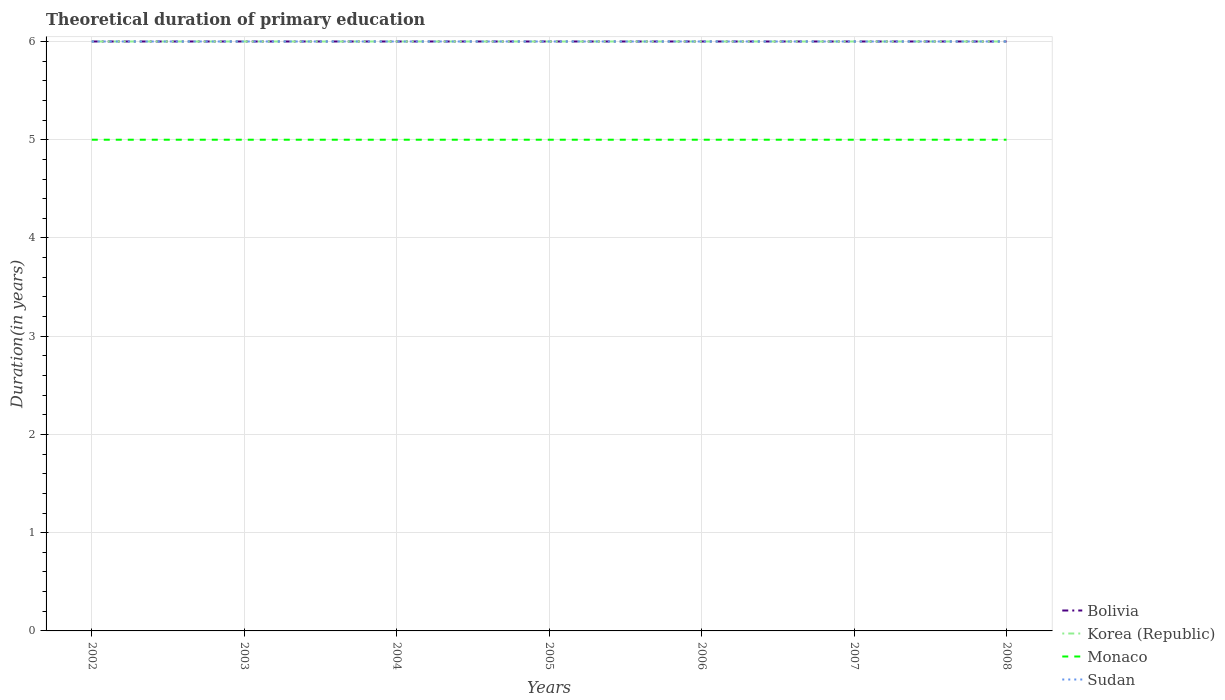How many different coloured lines are there?
Keep it short and to the point. 4. Across all years, what is the maximum total theoretical duration of primary education in Monaco?
Keep it short and to the point. 5. In which year was the total theoretical duration of primary education in Korea (Republic) maximum?
Make the answer very short. 2002. What is the difference between the highest and the second highest total theoretical duration of primary education in Sudan?
Your answer should be very brief. 0. Is the total theoretical duration of primary education in Korea (Republic) strictly greater than the total theoretical duration of primary education in Bolivia over the years?
Make the answer very short. No. Are the values on the major ticks of Y-axis written in scientific E-notation?
Make the answer very short. No. Does the graph contain grids?
Offer a very short reply. Yes. How are the legend labels stacked?
Your answer should be compact. Vertical. What is the title of the graph?
Ensure brevity in your answer.  Theoretical duration of primary education. Does "East Asia (developing only)" appear as one of the legend labels in the graph?
Make the answer very short. No. What is the label or title of the Y-axis?
Give a very brief answer. Duration(in years). What is the Duration(in years) in Bolivia in 2002?
Offer a very short reply. 6. What is the Duration(in years) of Korea (Republic) in 2002?
Provide a short and direct response. 6. What is the Duration(in years) of Monaco in 2002?
Offer a very short reply. 5. What is the Duration(in years) in Bolivia in 2003?
Provide a succinct answer. 6. What is the Duration(in years) of Korea (Republic) in 2003?
Offer a terse response. 6. What is the Duration(in years) of Monaco in 2003?
Offer a very short reply. 5. What is the Duration(in years) in Bolivia in 2004?
Your response must be concise. 6. What is the Duration(in years) in Korea (Republic) in 2004?
Give a very brief answer. 6. What is the Duration(in years) in Monaco in 2004?
Offer a terse response. 5. What is the Duration(in years) in Sudan in 2004?
Offer a terse response. 6. What is the Duration(in years) of Bolivia in 2005?
Make the answer very short. 6. What is the Duration(in years) of Korea (Republic) in 2005?
Your response must be concise. 6. What is the Duration(in years) of Monaco in 2006?
Your answer should be compact. 5. What is the Duration(in years) in Sudan in 2006?
Provide a succinct answer. 6. What is the Duration(in years) of Bolivia in 2007?
Offer a terse response. 6. What is the Duration(in years) in Monaco in 2008?
Your answer should be compact. 5. Across all years, what is the maximum Duration(in years) in Bolivia?
Offer a very short reply. 6. Across all years, what is the maximum Duration(in years) of Korea (Republic)?
Give a very brief answer. 6. Across all years, what is the maximum Duration(in years) of Monaco?
Provide a succinct answer. 5. Across all years, what is the minimum Duration(in years) of Monaco?
Ensure brevity in your answer.  5. What is the total Duration(in years) of Korea (Republic) in the graph?
Give a very brief answer. 42. What is the difference between the Duration(in years) in Bolivia in 2002 and that in 2004?
Your answer should be compact. 0. What is the difference between the Duration(in years) in Monaco in 2002 and that in 2004?
Ensure brevity in your answer.  0. What is the difference between the Duration(in years) of Sudan in 2002 and that in 2004?
Your response must be concise. 0. What is the difference between the Duration(in years) in Monaco in 2002 and that in 2005?
Offer a very short reply. 0. What is the difference between the Duration(in years) in Sudan in 2002 and that in 2005?
Provide a succinct answer. 0. What is the difference between the Duration(in years) of Korea (Republic) in 2002 and that in 2006?
Provide a short and direct response. 0. What is the difference between the Duration(in years) in Monaco in 2002 and that in 2006?
Make the answer very short. 0. What is the difference between the Duration(in years) of Bolivia in 2002 and that in 2008?
Offer a terse response. 0. What is the difference between the Duration(in years) in Korea (Republic) in 2002 and that in 2008?
Offer a terse response. 0. What is the difference between the Duration(in years) of Monaco in 2002 and that in 2008?
Provide a short and direct response. 0. What is the difference between the Duration(in years) in Korea (Republic) in 2003 and that in 2004?
Keep it short and to the point. 0. What is the difference between the Duration(in years) of Monaco in 2003 and that in 2004?
Give a very brief answer. 0. What is the difference between the Duration(in years) in Sudan in 2003 and that in 2004?
Offer a terse response. 0. What is the difference between the Duration(in years) in Monaco in 2003 and that in 2005?
Your response must be concise. 0. What is the difference between the Duration(in years) of Bolivia in 2003 and that in 2006?
Offer a terse response. 0. What is the difference between the Duration(in years) of Monaco in 2003 and that in 2006?
Give a very brief answer. 0. What is the difference between the Duration(in years) in Bolivia in 2003 and that in 2007?
Your answer should be very brief. 0. What is the difference between the Duration(in years) in Sudan in 2003 and that in 2008?
Offer a terse response. 0. What is the difference between the Duration(in years) in Korea (Republic) in 2004 and that in 2005?
Give a very brief answer. 0. What is the difference between the Duration(in years) in Sudan in 2004 and that in 2005?
Your response must be concise. 0. What is the difference between the Duration(in years) of Korea (Republic) in 2004 and that in 2006?
Give a very brief answer. 0. What is the difference between the Duration(in years) in Korea (Republic) in 2004 and that in 2007?
Make the answer very short. 0. What is the difference between the Duration(in years) in Monaco in 2004 and that in 2007?
Keep it short and to the point. 0. What is the difference between the Duration(in years) of Sudan in 2004 and that in 2007?
Your response must be concise. 0. What is the difference between the Duration(in years) in Korea (Republic) in 2004 and that in 2008?
Your answer should be compact. 0. What is the difference between the Duration(in years) of Sudan in 2004 and that in 2008?
Your response must be concise. 0. What is the difference between the Duration(in years) in Bolivia in 2005 and that in 2006?
Keep it short and to the point. 0. What is the difference between the Duration(in years) in Korea (Republic) in 2005 and that in 2006?
Ensure brevity in your answer.  0. What is the difference between the Duration(in years) of Bolivia in 2005 and that in 2007?
Offer a very short reply. 0. What is the difference between the Duration(in years) in Korea (Republic) in 2005 and that in 2008?
Your answer should be very brief. 0. What is the difference between the Duration(in years) in Monaco in 2005 and that in 2008?
Give a very brief answer. 0. What is the difference between the Duration(in years) in Bolivia in 2006 and that in 2008?
Give a very brief answer. 0. What is the difference between the Duration(in years) of Monaco in 2006 and that in 2008?
Ensure brevity in your answer.  0. What is the difference between the Duration(in years) in Monaco in 2007 and that in 2008?
Your response must be concise. 0. What is the difference between the Duration(in years) in Bolivia in 2002 and the Duration(in years) in Korea (Republic) in 2003?
Keep it short and to the point. 0. What is the difference between the Duration(in years) of Korea (Republic) in 2002 and the Duration(in years) of Monaco in 2003?
Offer a very short reply. 1. What is the difference between the Duration(in years) of Bolivia in 2002 and the Duration(in years) of Sudan in 2004?
Your answer should be compact. 0. What is the difference between the Duration(in years) in Korea (Republic) in 2002 and the Duration(in years) in Monaco in 2004?
Ensure brevity in your answer.  1. What is the difference between the Duration(in years) in Monaco in 2002 and the Duration(in years) in Sudan in 2004?
Give a very brief answer. -1. What is the difference between the Duration(in years) in Bolivia in 2002 and the Duration(in years) in Monaco in 2005?
Ensure brevity in your answer.  1. What is the difference between the Duration(in years) of Bolivia in 2002 and the Duration(in years) of Korea (Republic) in 2006?
Offer a very short reply. 0. What is the difference between the Duration(in years) of Bolivia in 2002 and the Duration(in years) of Monaco in 2006?
Your answer should be very brief. 1. What is the difference between the Duration(in years) of Bolivia in 2002 and the Duration(in years) of Sudan in 2006?
Ensure brevity in your answer.  0. What is the difference between the Duration(in years) in Korea (Republic) in 2002 and the Duration(in years) in Monaco in 2006?
Keep it short and to the point. 1. What is the difference between the Duration(in years) in Korea (Republic) in 2002 and the Duration(in years) in Sudan in 2006?
Ensure brevity in your answer.  0. What is the difference between the Duration(in years) of Bolivia in 2002 and the Duration(in years) of Korea (Republic) in 2007?
Ensure brevity in your answer.  0. What is the difference between the Duration(in years) of Bolivia in 2002 and the Duration(in years) of Sudan in 2008?
Provide a succinct answer. 0. What is the difference between the Duration(in years) in Korea (Republic) in 2002 and the Duration(in years) in Monaco in 2008?
Keep it short and to the point. 1. What is the difference between the Duration(in years) of Monaco in 2002 and the Duration(in years) of Sudan in 2008?
Provide a succinct answer. -1. What is the difference between the Duration(in years) of Bolivia in 2003 and the Duration(in years) of Monaco in 2004?
Your answer should be compact. 1. What is the difference between the Duration(in years) in Monaco in 2003 and the Duration(in years) in Sudan in 2004?
Provide a succinct answer. -1. What is the difference between the Duration(in years) of Korea (Republic) in 2003 and the Duration(in years) of Sudan in 2005?
Offer a very short reply. 0. What is the difference between the Duration(in years) in Monaco in 2003 and the Duration(in years) in Sudan in 2005?
Keep it short and to the point. -1. What is the difference between the Duration(in years) of Korea (Republic) in 2003 and the Duration(in years) of Monaco in 2006?
Your response must be concise. 1. What is the difference between the Duration(in years) of Bolivia in 2003 and the Duration(in years) of Monaco in 2007?
Your response must be concise. 1. What is the difference between the Duration(in years) of Korea (Republic) in 2003 and the Duration(in years) of Monaco in 2007?
Provide a succinct answer. 1. What is the difference between the Duration(in years) of Korea (Republic) in 2003 and the Duration(in years) of Sudan in 2007?
Offer a terse response. 0. What is the difference between the Duration(in years) in Monaco in 2003 and the Duration(in years) in Sudan in 2007?
Offer a very short reply. -1. What is the difference between the Duration(in years) in Bolivia in 2003 and the Duration(in years) in Korea (Republic) in 2008?
Offer a very short reply. 0. What is the difference between the Duration(in years) of Bolivia in 2003 and the Duration(in years) of Sudan in 2008?
Provide a succinct answer. 0. What is the difference between the Duration(in years) of Korea (Republic) in 2003 and the Duration(in years) of Monaco in 2008?
Keep it short and to the point. 1. What is the difference between the Duration(in years) in Korea (Republic) in 2004 and the Duration(in years) in Sudan in 2005?
Your answer should be very brief. 0. What is the difference between the Duration(in years) in Bolivia in 2004 and the Duration(in years) in Sudan in 2006?
Ensure brevity in your answer.  0. What is the difference between the Duration(in years) in Korea (Republic) in 2004 and the Duration(in years) in Monaco in 2006?
Offer a very short reply. 1. What is the difference between the Duration(in years) of Korea (Republic) in 2004 and the Duration(in years) of Sudan in 2006?
Make the answer very short. 0. What is the difference between the Duration(in years) of Bolivia in 2004 and the Duration(in years) of Korea (Republic) in 2007?
Offer a terse response. 0. What is the difference between the Duration(in years) in Korea (Republic) in 2004 and the Duration(in years) in Monaco in 2007?
Your response must be concise. 1. What is the difference between the Duration(in years) of Korea (Republic) in 2004 and the Duration(in years) of Sudan in 2007?
Offer a very short reply. 0. What is the difference between the Duration(in years) of Bolivia in 2004 and the Duration(in years) of Korea (Republic) in 2008?
Make the answer very short. 0. What is the difference between the Duration(in years) in Bolivia in 2004 and the Duration(in years) in Monaco in 2008?
Make the answer very short. 1. What is the difference between the Duration(in years) in Monaco in 2004 and the Duration(in years) in Sudan in 2008?
Keep it short and to the point. -1. What is the difference between the Duration(in years) of Bolivia in 2005 and the Duration(in years) of Monaco in 2006?
Your answer should be very brief. 1. What is the difference between the Duration(in years) of Korea (Republic) in 2005 and the Duration(in years) of Monaco in 2006?
Keep it short and to the point. 1. What is the difference between the Duration(in years) of Korea (Republic) in 2005 and the Duration(in years) of Sudan in 2006?
Provide a short and direct response. 0. What is the difference between the Duration(in years) of Bolivia in 2005 and the Duration(in years) of Sudan in 2007?
Make the answer very short. 0. What is the difference between the Duration(in years) of Korea (Republic) in 2005 and the Duration(in years) of Monaco in 2007?
Your response must be concise. 1. What is the difference between the Duration(in years) in Korea (Republic) in 2005 and the Duration(in years) in Sudan in 2007?
Provide a succinct answer. 0. What is the difference between the Duration(in years) of Bolivia in 2005 and the Duration(in years) of Korea (Republic) in 2008?
Offer a very short reply. 0. What is the difference between the Duration(in years) of Bolivia in 2005 and the Duration(in years) of Monaco in 2008?
Make the answer very short. 1. What is the difference between the Duration(in years) in Bolivia in 2005 and the Duration(in years) in Sudan in 2008?
Give a very brief answer. 0. What is the difference between the Duration(in years) of Korea (Republic) in 2005 and the Duration(in years) of Monaco in 2008?
Your answer should be very brief. 1. What is the difference between the Duration(in years) in Monaco in 2005 and the Duration(in years) in Sudan in 2008?
Provide a succinct answer. -1. What is the difference between the Duration(in years) in Bolivia in 2006 and the Duration(in years) in Monaco in 2007?
Keep it short and to the point. 1. What is the difference between the Duration(in years) in Korea (Republic) in 2006 and the Duration(in years) in Sudan in 2007?
Provide a short and direct response. 0. What is the difference between the Duration(in years) of Bolivia in 2006 and the Duration(in years) of Korea (Republic) in 2008?
Provide a short and direct response. 0. What is the difference between the Duration(in years) of Bolivia in 2006 and the Duration(in years) of Monaco in 2008?
Make the answer very short. 1. What is the difference between the Duration(in years) in Korea (Republic) in 2006 and the Duration(in years) in Monaco in 2008?
Offer a very short reply. 1. What is the difference between the Duration(in years) of Korea (Republic) in 2006 and the Duration(in years) of Sudan in 2008?
Provide a succinct answer. 0. What is the difference between the Duration(in years) of Monaco in 2006 and the Duration(in years) of Sudan in 2008?
Offer a terse response. -1. What is the difference between the Duration(in years) in Bolivia in 2007 and the Duration(in years) in Sudan in 2008?
Provide a succinct answer. 0. What is the difference between the Duration(in years) of Monaco in 2007 and the Duration(in years) of Sudan in 2008?
Offer a very short reply. -1. What is the average Duration(in years) of Korea (Republic) per year?
Your answer should be very brief. 6. What is the average Duration(in years) of Monaco per year?
Ensure brevity in your answer.  5. In the year 2002, what is the difference between the Duration(in years) in Korea (Republic) and Duration(in years) in Sudan?
Give a very brief answer. 0. In the year 2003, what is the difference between the Duration(in years) of Bolivia and Duration(in years) of Korea (Republic)?
Make the answer very short. 0. In the year 2003, what is the difference between the Duration(in years) of Bolivia and Duration(in years) of Sudan?
Provide a short and direct response. 0. In the year 2003, what is the difference between the Duration(in years) of Korea (Republic) and Duration(in years) of Monaco?
Your answer should be very brief. 1. In the year 2003, what is the difference between the Duration(in years) of Korea (Republic) and Duration(in years) of Sudan?
Your answer should be very brief. 0. In the year 2003, what is the difference between the Duration(in years) of Monaco and Duration(in years) of Sudan?
Your answer should be compact. -1. In the year 2004, what is the difference between the Duration(in years) of Bolivia and Duration(in years) of Monaco?
Ensure brevity in your answer.  1. In the year 2004, what is the difference between the Duration(in years) in Korea (Republic) and Duration(in years) in Monaco?
Keep it short and to the point. 1. In the year 2004, what is the difference between the Duration(in years) of Korea (Republic) and Duration(in years) of Sudan?
Your answer should be very brief. 0. In the year 2004, what is the difference between the Duration(in years) of Monaco and Duration(in years) of Sudan?
Give a very brief answer. -1. In the year 2005, what is the difference between the Duration(in years) of Bolivia and Duration(in years) of Korea (Republic)?
Ensure brevity in your answer.  0. In the year 2005, what is the difference between the Duration(in years) in Bolivia and Duration(in years) in Monaco?
Provide a succinct answer. 1. In the year 2005, what is the difference between the Duration(in years) of Bolivia and Duration(in years) of Sudan?
Give a very brief answer. 0. In the year 2005, what is the difference between the Duration(in years) of Korea (Republic) and Duration(in years) of Monaco?
Your answer should be compact. 1. In the year 2005, what is the difference between the Duration(in years) in Monaco and Duration(in years) in Sudan?
Your response must be concise. -1. In the year 2006, what is the difference between the Duration(in years) in Bolivia and Duration(in years) in Korea (Republic)?
Provide a short and direct response. 0. In the year 2006, what is the difference between the Duration(in years) in Bolivia and Duration(in years) in Monaco?
Offer a terse response. 1. In the year 2006, what is the difference between the Duration(in years) in Bolivia and Duration(in years) in Sudan?
Keep it short and to the point. 0. In the year 2006, what is the difference between the Duration(in years) of Korea (Republic) and Duration(in years) of Monaco?
Keep it short and to the point. 1. In the year 2007, what is the difference between the Duration(in years) of Bolivia and Duration(in years) of Korea (Republic)?
Keep it short and to the point. 0. In the year 2007, what is the difference between the Duration(in years) of Bolivia and Duration(in years) of Monaco?
Provide a succinct answer. 1. In the year 2007, what is the difference between the Duration(in years) in Korea (Republic) and Duration(in years) in Monaco?
Offer a very short reply. 1. In the year 2007, what is the difference between the Duration(in years) of Korea (Republic) and Duration(in years) of Sudan?
Offer a terse response. 0. In the year 2007, what is the difference between the Duration(in years) in Monaco and Duration(in years) in Sudan?
Provide a short and direct response. -1. In the year 2008, what is the difference between the Duration(in years) in Bolivia and Duration(in years) in Korea (Republic)?
Make the answer very short. 0. In the year 2008, what is the difference between the Duration(in years) of Bolivia and Duration(in years) of Sudan?
Your answer should be very brief. 0. In the year 2008, what is the difference between the Duration(in years) in Korea (Republic) and Duration(in years) in Sudan?
Provide a succinct answer. 0. In the year 2008, what is the difference between the Duration(in years) of Monaco and Duration(in years) of Sudan?
Your answer should be very brief. -1. What is the ratio of the Duration(in years) of Bolivia in 2002 to that in 2003?
Keep it short and to the point. 1. What is the ratio of the Duration(in years) of Korea (Republic) in 2002 to that in 2003?
Provide a short and direct response. 1. What is the ratio of the Duration(in years) of Monaco in 2002 to that in 2003?
Offer a terse response. 1. What is the ratio of the Duration(in years) in Sudan in 2002 to that in 2003?
Provide a short and direct response. 1. What is the ratio of the Duration(in years) of Korea (Republic) in 2002 to that in 2004?
Make the answer very short. 1. What is the ratio of the Duration(in years) in Monaco in 2002 to that in 2004?
Offer a terse response. 1. What is the ratio of the Duration(in years) of Sudan in 2002 to that in 2004?
Ensure brevity in your answer.  1. What is the ratio of the Duration(in years) in Bolivia in 2002 to that in 2005?
Provide a short and direct response. 1. What is the ratio of the Duration(in years) in Sudan in 2002 to that in 2005?
Ensure brevity in your answer.  1. What is the ratio of the Duration(in years) of Sudan in 2002 to that in 2006?
Your answer should be very brief. 1. What is the ratio of the Duration(in years) of Korea (Republic) in 2002 to that in 2007?
Offer a terse response. 1. What is the ratio of the Duration(in years) of Monaco in 2002 to that in 2007?
Provide a short and direct response. 1. What is the ratio of the Duration(in years) in Sudan in 2002 to that in 2007?
Make the answer very short. 1. What is the ratio of the Duration(in years) in Bolivia in 2002 to that in 2008?
Give a very brief answer. 1. What is the ratio of the Duration(in years) of Sudan in 2002 to that in 2008?
Make the answer very short. 1. What is the ratio of the Duration(in years) in Korea (Republic) in 2003 to that in 2004?
Ensure brevity in your answer.  1. What is the ratio of the Duration(in years) of Monaco in 2003 to that in 2005?
Your answer should be compact. 1. What is the ratio of the Duration(in years) of Sudan in 2003 to that in 2005?
Provide a short and direct response. 1. What is the ratio of the Duration(in years) of Bolivia in 2003 to that in 2006?
Offer a terse response. 1. What is the ratio of the Duration(in years) of Korea (Republic) in 2003 to that in 2006?
Give a very brief answer. 1. What is the ratio of the Duration(in years) in Monaco in 2003 to that in 2006?
Your answer should be very brief. 1. What is the ratio of the Duration(in years) in Sudan in 2003 to that in 2006?
Offer a terse response. 1. What is the ratio of the Duration(in years) in Korea (Republic) in 2003 to that in 2007?
Your response must be concise. 1. What is the ratio of the Duration(in years) in Sudan in 2003 to that in 2007?
Make the answer very short. 1. What is the ratio of the Duration(in years) in Sudan in 2003 to that in 2008?
Provide a short and direct response. 1. What is the ratio of the Duration(in years) in Korea (Republic) in 2004 to that in 2005?
Provide a succinct answer. 1. What is the ratio of the Duration(in years) of Monaco in 2004 to that in 2005?
Give a very brief answer. 1. What is the ratio of the Duration(in years) in Monaco in 2004 to that in 2006?
Give a very brief answer. 1. What is the ratio of the Duration(in years) of Korea (Republic) in 2004 to that in 2008?
Ensure brevity in your answer.  1. What is the ratio of the Duration(in years) in Sudan in 2004 to that in 2008?
Your response must be concise. 1. What is the ratio of the Duration(in years) in Bolivia in 2005 to that in 2006?
Ensure brevity in your answer.  1. What is the ratio of the Duration(in years) of Monaco in 2005 to that in 2006?
Make the answer very short. 1. What is the ratio of the Duration(in years) of Monaco in 2005 to that in 2007?
Your response must be concise. 1. What is the ratio of the Duration(in years) of Bolivia in 2005 to that in 2008?
Give a very brief answer. 1. What is the ratio of the Duration(in years) of Sudan in 2005 to that in 2008?
Make the answer very short. 1. What is the ratio of the Duration(in years) of Bolivia in 2006 to that in 2007?
Your answer should be very brief. 1. What is the ratio of the Duration(in years) of Korea (Republic) in 2006 to that in 2007?
Keep it short and to the point. 1. What is the ratio of the Duration(in years) of Monaco in 2006 to that in 2007?
Your response must be concise. 1. What is the ratio of the Duration(in years) of Sudan in 2006 to that in 2007?
Your response must be concise. 1. What is the ratio of the Duration(in years) of Bolivia in 2007 to that in 2008?
Ensure brevity in your answer.  1. What is the ratio of the Duration(in years) in Korea (Republic) in 2007 to that in 2008?
Give a very brief answer. 1. What is the ratio of the Duration(in years) of Monaco in 2007 to that in 2008?
Make the answer very short. 1. What is the ratio of the Duration(in years) in Sudan in 2007 to that in 2008?
Keep it short and to the point. 1. What is the difference between the highest and the second highest Duration(in years) of Monaco?
Your response must be concise. 0. What is the difference between the highest and the second highest Duration(in years) of Sudan?
Make the answer very short. 0. What is the difference between the highest and the lowest Duration(in years) of Bolivia?
Offer a terse response. 0. What is the difference between the highest and the lowest Duration(in years) in Sudan?
Offer a terse response. 0. 